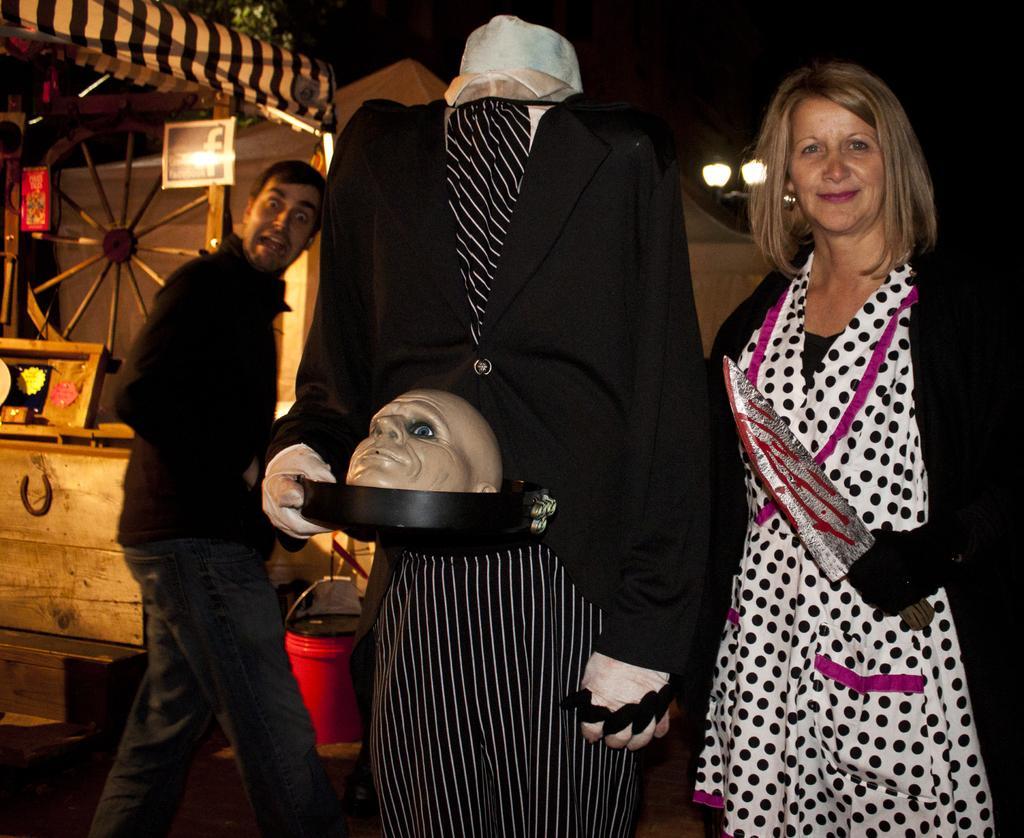Describe this image in one or two sentences. In this image, we can see persons wearing clothes. There is a statue in the middle of the image. There is a wheel and tent in the top left of the image. There is a wooden box on the left side of the image. There is a bucket at the bottom of the image. 